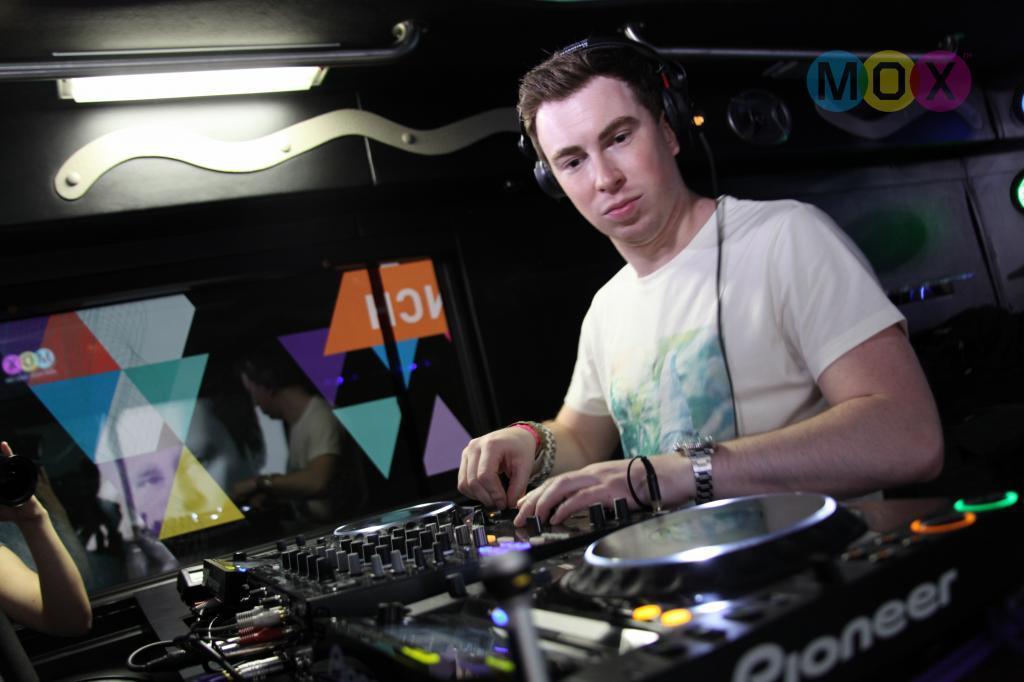How would you summarize this image in a sentence or two? There is a person wearing a headset and watch. In front of him there is a DJ mixer. In the back there is a glass wall. On the left side we can see a person's hand with camera. 